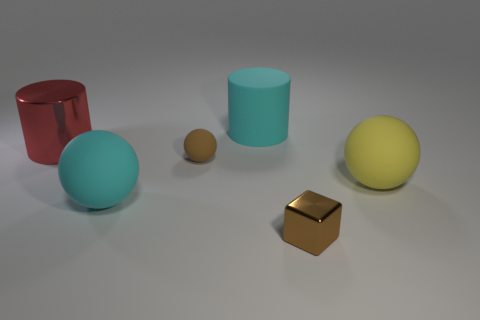What number of cylinders are brown rubber objects or big metallic objects?
Offer a terse response. 1. Are there an equal number of tiny brown blocks that are on the left side of the big cyan cylinder and red cylinders on the left side of the big yellow rubber sphere?
Offer a very short reply. No. What number of big cyan rubber things are in front of the cyan matte object behind the red cylinder on the left side of the brown cube?
Your response must be concise. 1. There is a big rubber thing that is the same color as the matte cylinder; what is its shape?
Offer a terse response. Sphere. Do the tiny shiny block and the matte sphere that is behind the yellow rubber sphere have the same color?
Keep it short and to the point. Yes. Is the number of big balls that are on the right side of the brown cube greater than the number of small yellow objects?
Provide a succinct answer. Yes. How many objects are either red metal things to the left of the big matte cylinder or objects in front of the cyan cylinder?
Give a very brief answer. 5. The cyan ball that is the same material as the big yellow object is what size?
Your response must be concise. Large. Does the cyan thing that is to the right of the big cyan rubber sphere have the same shape as the big red object?
Offer a very short reply. Yes. There is a thing that is the same color as the block; what size is it?
Offer a very short reply. Small. 